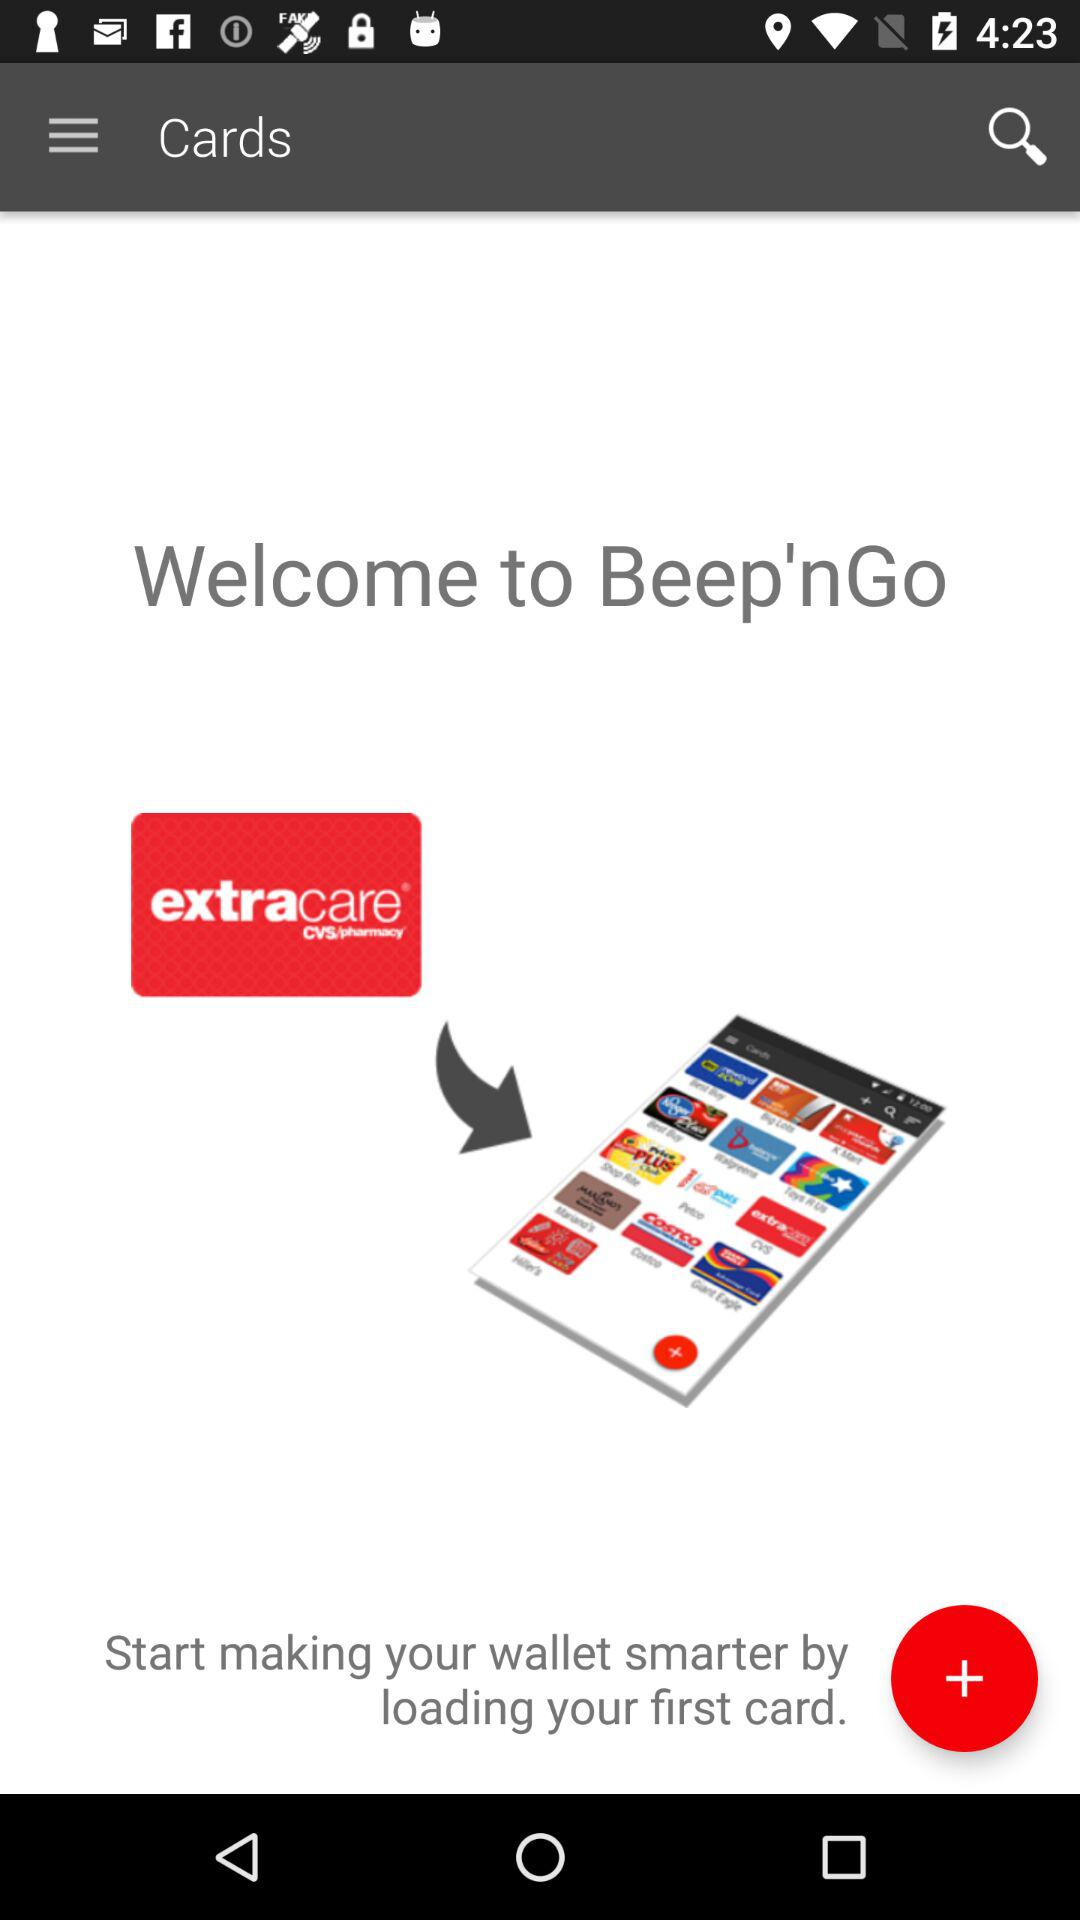Who signed up for "Beep'nGo"?
When the provided information is insufficient, respond with <no answer>. <no answer> 